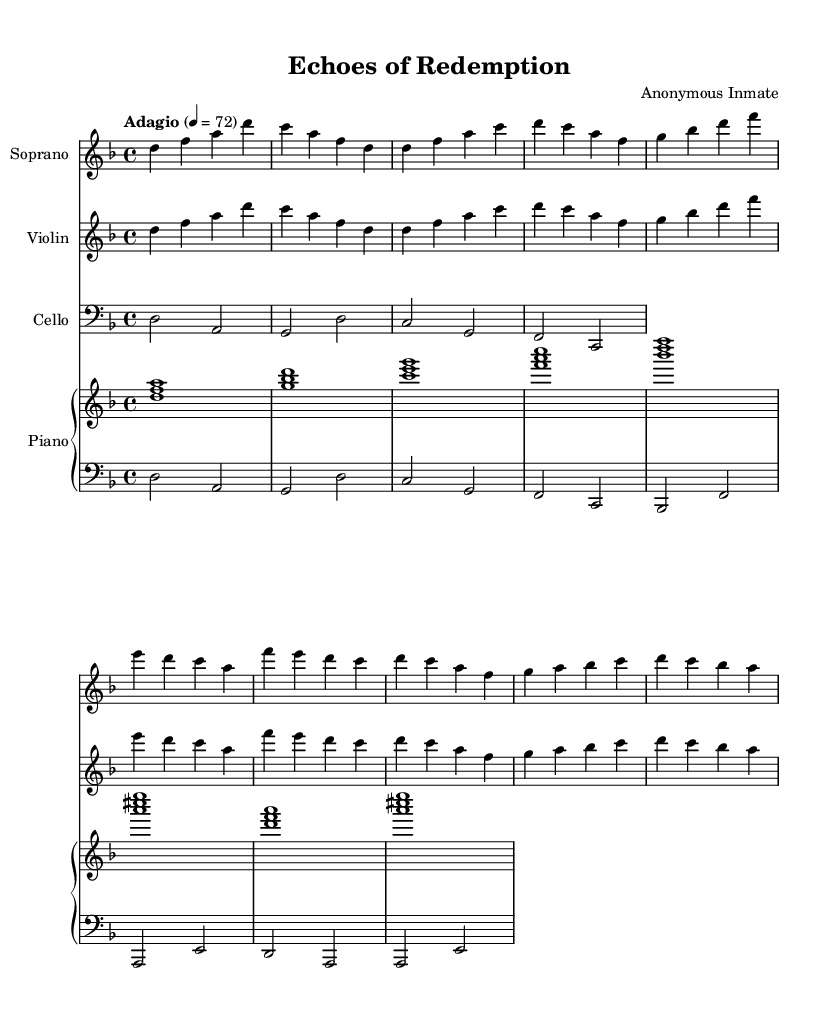What is the key signature of this music? The key signature is D minor, indicated by one flat (B flat) at the beginning of the staff.
Answer: D minor What is the time signature of this piece? The time signature is 4/4, showing that there are four beats in each measure and the quarter note gets one beat.
Answer: 4/4 What is the tempo marking for this composition? The tempo marking is "Adagio", which indicates a slow tempo. This is noted at the beginning of the score.
Answer: Adagio How many measures are in the introduction? The introduction contains two measures, visible at the start of both the soprano and violin parts.
Answer: 2 What thematic element is expressed in the chorus lyrics? The chorus lyrics express a desire for justice and freedom, highlighting themes of societal change. This is derived from the phrases "justice blind" and "to set us free".
Answer: Justice Which instruments are included in the score? The score includes soprano, violin, cello, and piano, as indicated by the separate staves for each instrument.
Answer: Soprano, Violin, Cello, Piano What is the lowest note in the cello part? The lowest note in the cello part is D, which is played in the second measure.
Answer: D 